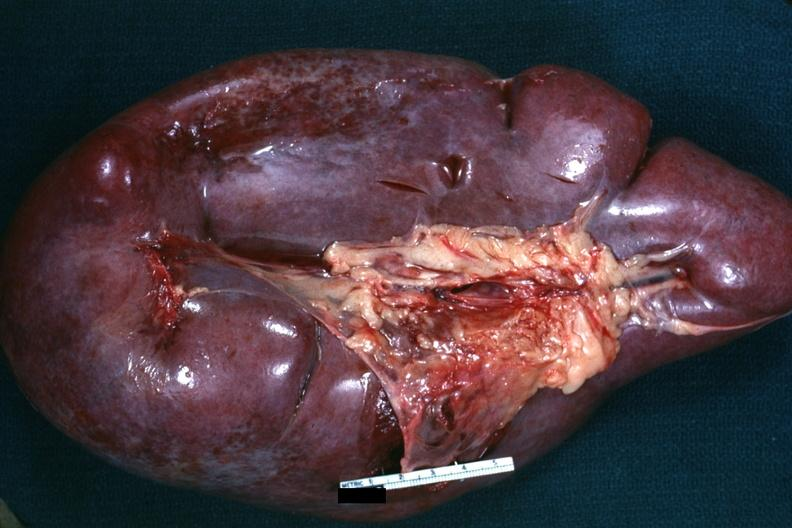does subcapsular hematoma show external view of massively enlarged spleen?
Answer the question using a single word or phrase. No 